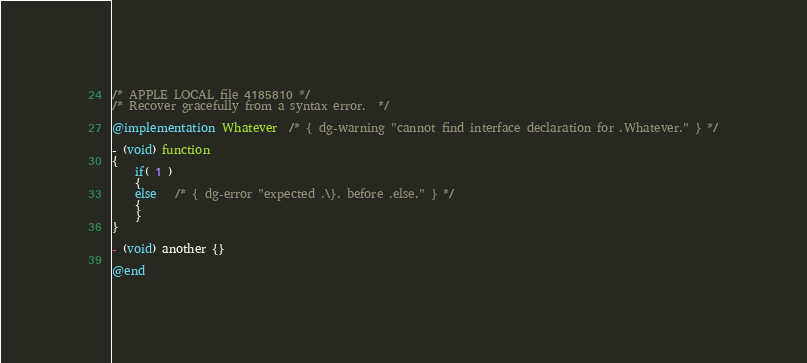Convert code to text. <code><loc_0><loc_0><loc_500><loc_500><_ObjectiveC_>/* APPLE LOCAL file 4185810 */
/* Recover gracefully from a syntax error.  */

@implementation Whatever  /* { dg-warning "cannot find interface declaration for .Whatever." } */

- (void) function
{
	if( 1 )
	{
	else   /* { dg-error "expected .\}. before .else." } */
	{
	}
}

- (void) another {}

@end
</code> 